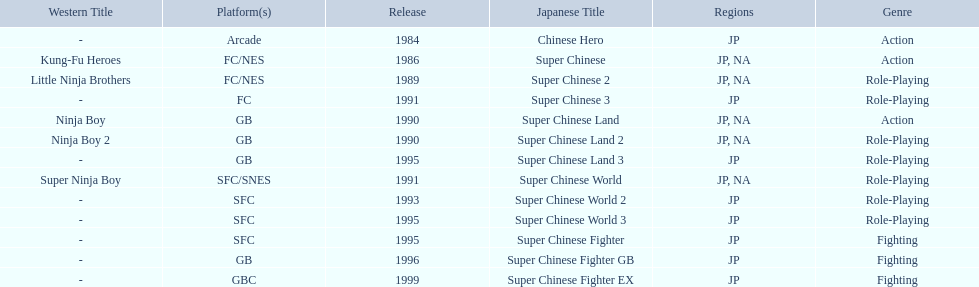What japanese titles were released in the north american (na) region? Super Chinese, Super Chinese 2, Super Chinese Land, Super Chinese Land 2, Super Chinese World. Of those, which one was released most recently? Super Chinese World. 